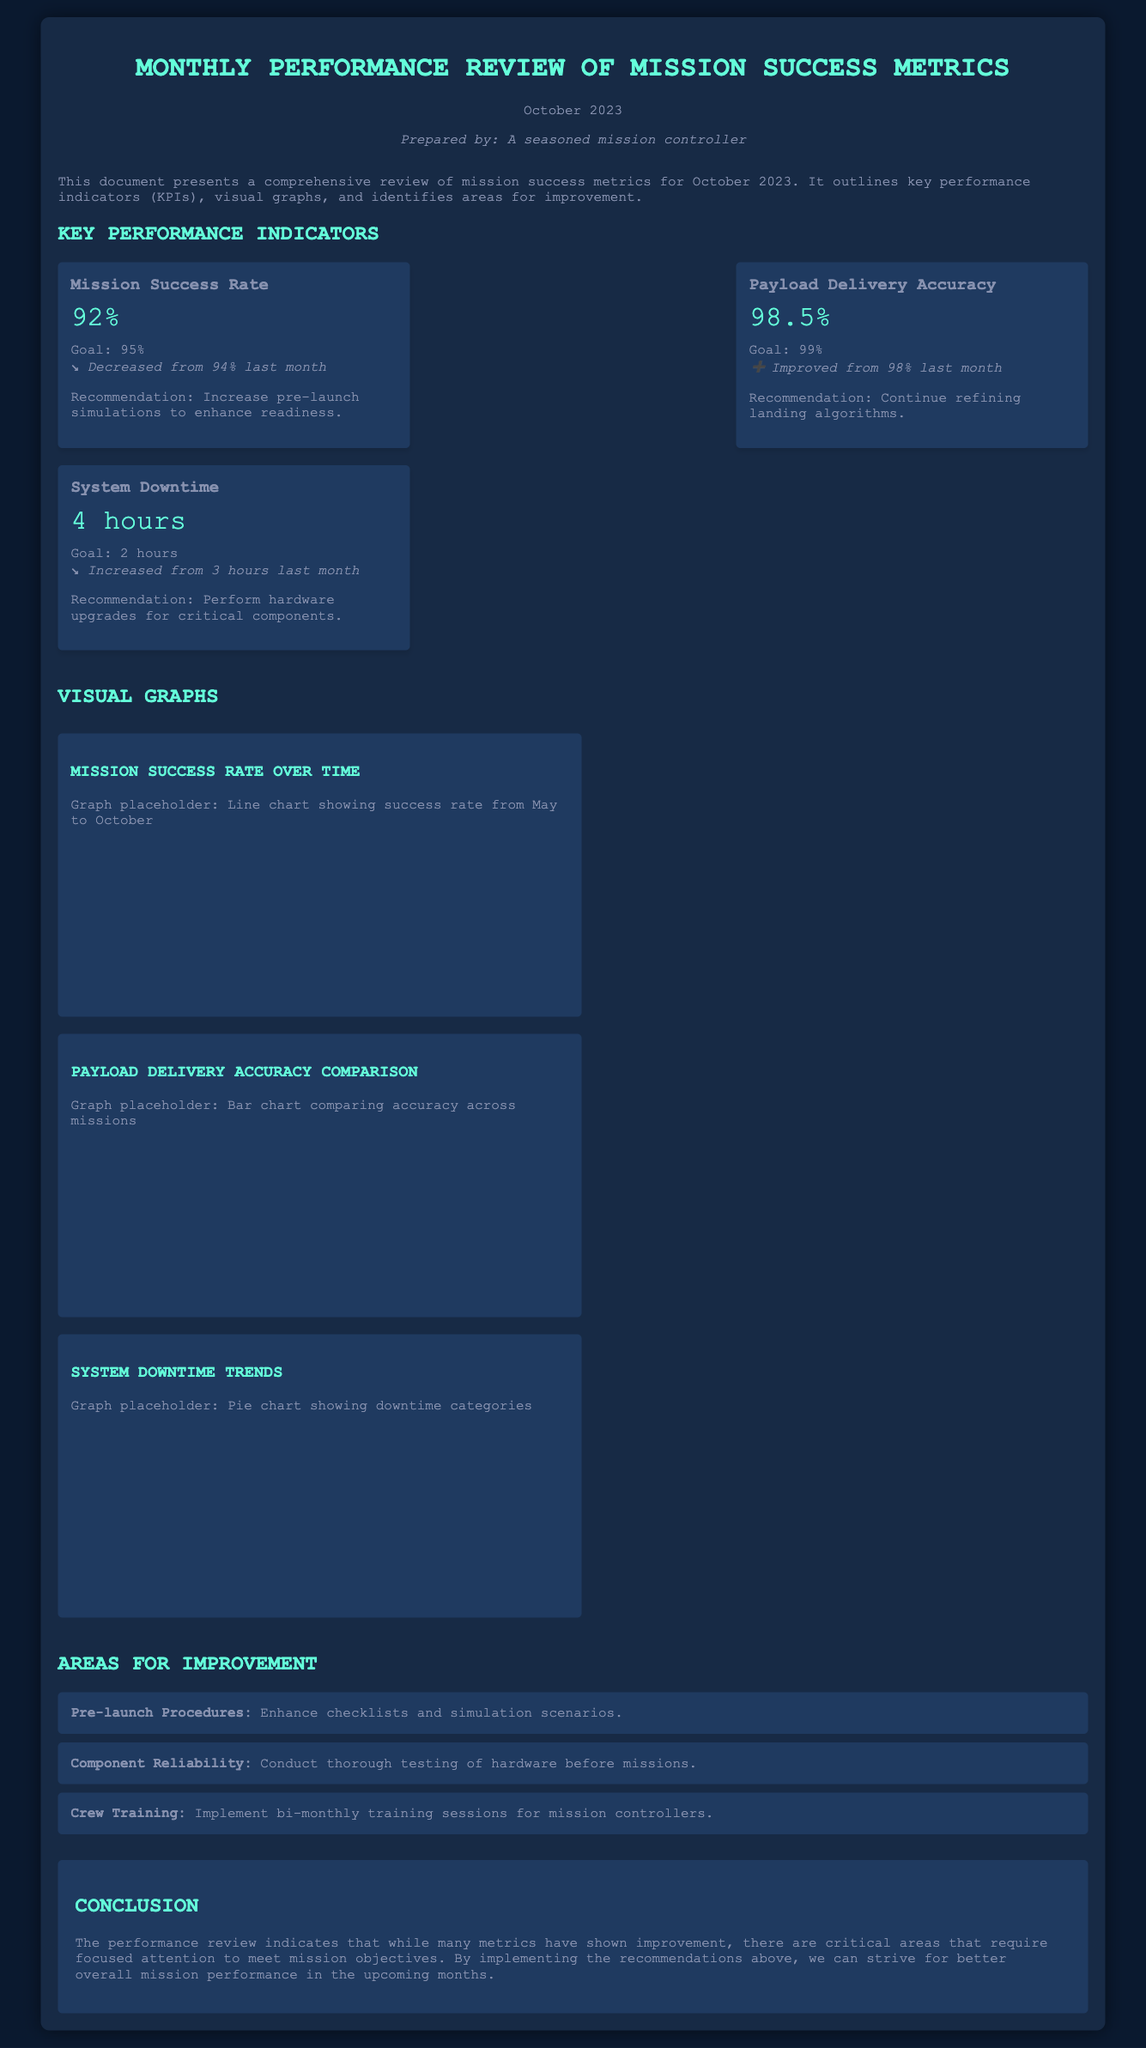What is the mission success rate for October 2023? The mission success rate is stated as 92% in the document.
Answer: 92% What was the previous month's success rate? The previous month's success rate was 94%, which is indicated in the trend for the mission success rate.
Answer: 94% What is the goal for payload delivery accuracy? The goal for payload delivery accuracy is provided as 99% in the document.
Answer: 99% How many hours of system downtime were recorded? The document specifies that there were 4 hours of system downtime.
Answer: 4 hours What is the recommendation for mission success rate improvement? The document suggests increasing pre-launch simulations to enhance readiness.
Answer: Increase pre-launch simulations What percentage of payload delivery accuracy was achieved? The achieved payload delivery accuracy is indicated as 98.5% in the KPI section.
Answer: 98.5% What type of graph is suggested for showing success rate over time? The document states that a line chart should be used to show success rate over time.
Answer: Line chart Which area for improvement is related to crew training? The document mentions implementing bi-monthly training sessions for mission controllers under crew training.
Answer: Bi-monthly training sessions What is the trend for system downtime compared to last month? The trend indicates that system downtime has increased from 3 hours last month.
Answer: Increased What month is this performance review reporting on? The performance review is reporting on October 2023.
Answer: October 2023 